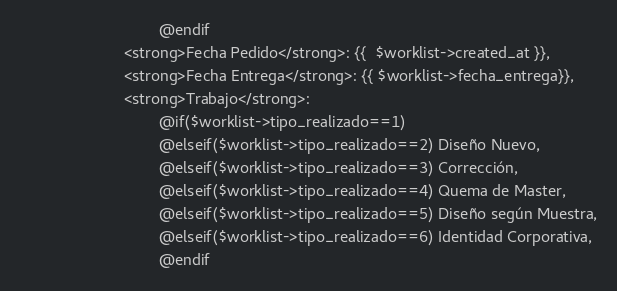Convert code to text. <code><loc_0><loc_0><loc_500><loc_500><_PHP_>								@endif 
						<strong>Fecha Pedido</strong>: {{  $worklist->created_at }},
                        <strong>Fecha Entrega</strong>: {{ $worklist->fecha_entrega}},
						<strong>Trabajo</strong>: 
								@if($worklist->tipo_realizado==1)	                             
								@elseif($worklist->tipo_realizado==2) Diseño Nuevo,
								@elseif($worklist->tipo_realizado==3) Corrección,
								@elseif($worklist->tipo_realizado==4) Quema de Master,
								@elseif($worklist->tipo_realizado==5) Diseño según Muestra,
								@elseif($worklist->tipo_realizado==6) Identidad Corporativa,
								@endif</code> 